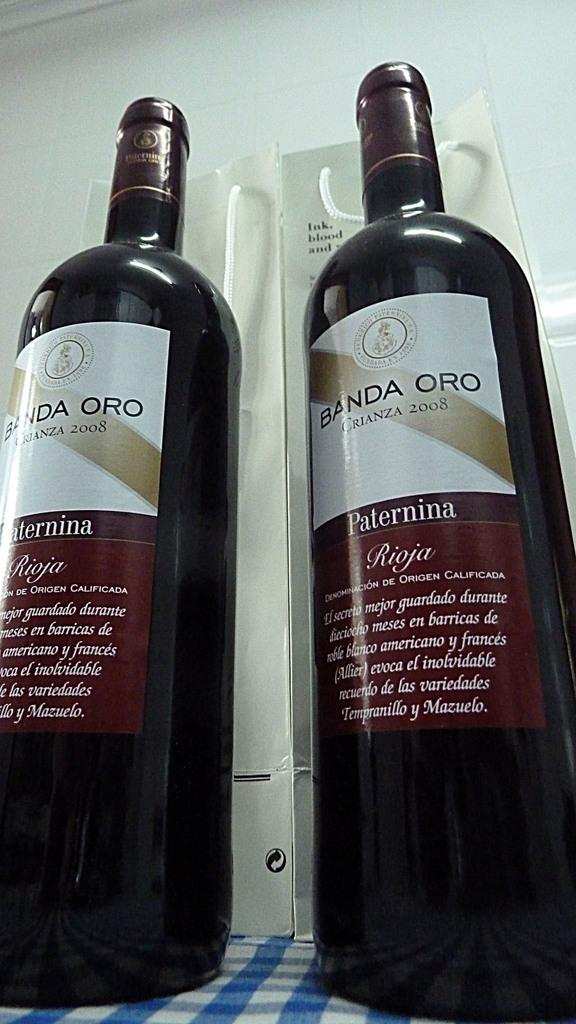<image>
Create a compact narrative representing the image presented. Two bottles of Banda Oro sit next to each other on a blue checkered table 